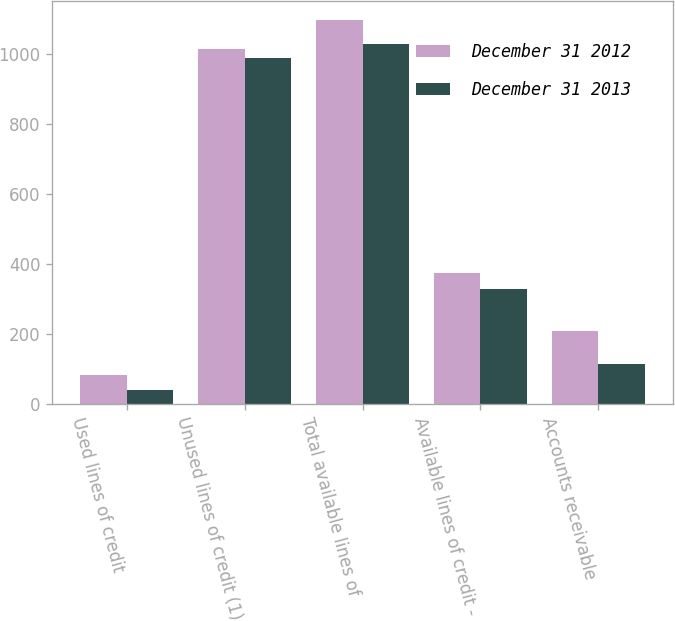<chart> <loc_0><loc_0><loc_500><loc_500><stacked_bar_chart><ecel><fcel>Used lines of credit<fcel>Unused lines of credit (1)<fcel>Total available lines of<fcel>Available lines of credit -<fcel>Accounts receivable<nl><fcel>December 31 2012<fcel>81.6<fcel>1015<fcel>1096.6<fcel>374.7<fcel>209<nl><fcel>December 31 2013<fcel>39.2<fcel>989.5<fcel>1028.7<fcel>328.2<fcel>112<nl></chart> 